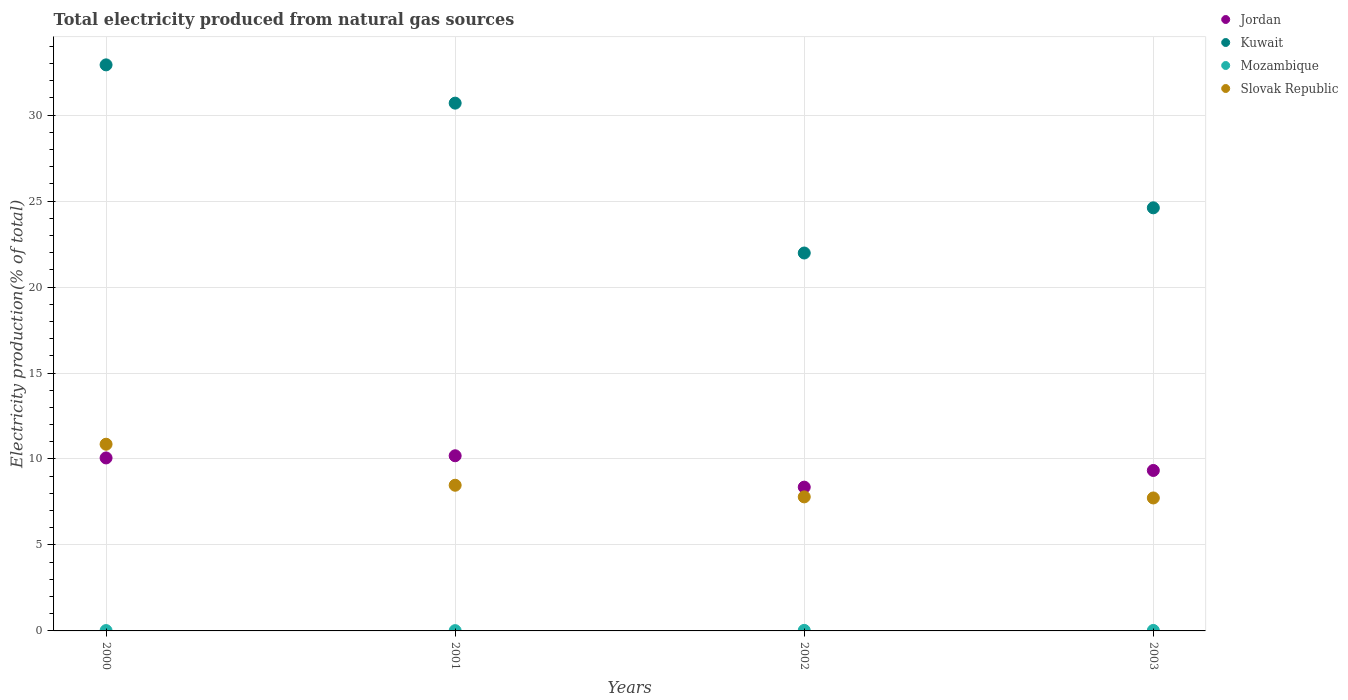Is the number of dotlines equal to the number of legend labels?
Provide a short and direct response. Yes. What is the total electricity produced in Slovak Republic in 2000?
Provide a short and direct response. 10.86. Across all years, what is the maximum total electricity produced in Kuwait?
Give a very brief answer. 32.92. Across all years, what is the minimum total electricity produced in Kuwait?
Your response must be concise. 21.98. What is the total total electricity produced in Slovak Republic in the graph?
Your response must be concise. 34.86. What is the difference between the total electricity produced in Mozambique in 2000 and that in 2002?
Ensure brevity in your answer.  -0.01. What is the difference between the total electricity produced in Mozambique in 2003 and the total electricity produced in Slovak Republic in 2000?
Your response must be concise. -10.83. What is the average total electricity produced in Jordan per year?
Make the answer very short. 9.49. In the year 2003, what is the difference between the total electricity produced in Mozambique and total electricity produced in Jordan?
Offer a terse response. -9.3. In how many years, is the total electricity produced in Slovak Republic greater than 31 %?
Your response must be concise. 0. What is the ratio of the total electricity produced in Jordan in 2001 to that in 2003?
Provide a short and direct response. 1.09. Is the difference between the total electricity produced in Mozambique in 2000 and 2002 greater than the difference between the total electricity produced in Jordan in 2000 and 2002?
Make the answer very short. No. What is the difference between the highest and the second highest total electricity produced in Kuwait?
Make the answer very short. 2.23. What is the difference between the highest and the lowest total electricity produced in Mozambique?
Your answer should be compact. 0.01. In how many years, is the total electricity produced in Mozambique greater than the average total electricity produced in Mozambique taken over all years?
Ensure brevity in your answer.  2. Is the sum of the total electricity produced in Mozambique in 2002 and 2003 greater than the maximum total electricity produced in Slovak Republic across all years?
Offer a very short reply. No. Is the total electricity produced in Kuwait strictly less than the total electricity produced in Mozambique over the years?
Your answer should be compact. No. How many years are there in the graph?
Offer a terse response. 4. What is the difference between two consecutive major ticks on the Y-axis?
Provide a short and direct response. 5. Are the values on the major ticks of Y-axis written in scientific E-notation?
Offer a very short reply. No. What is the title of the graph?
Your answer should be very brief. Total electricity produced from natural gas sources. What is the label or title of the X-axis?
Your answer should be compact. Years. What is the Electricity production(% of total) in Jordan in 2000?
Offer a very short reply. 10.06. What is the Electricity production(% of total) in Kuwait in 2000?
Provide a succinct answer. 32.92. What is the Electricity production(% of total) in Mozambique in 2000?
Provide a short and direct response. 0.02. What is the Electricity production(% of total) in Slovak Republic in 2000?
Offer a very short reply. 10.86. What is the Electricity production(% of total) of Jordan in 2001?
Ensure brevity in your answer.  10.19. What is the Electricity production(% of total) in Kuwait in 2001?
Provide a short and direct response. 30.69. What is the Electricity production(% of total) of Mozambique in 2001?
Give a very brief answer. 0.02. What is the Electricity production(% of total) of Slovak Republic in 2001?
Keep it short and to the point. 8.47. What is the Electricity production(% of total) of Jordan in 2002?
Provide a succinct answer. 8.36. What is the Electricity production(% of total) of Kuwait in 2002?
Give a very brief answer. 21.98. What is the Electricity production(% of total) in Mozambique in 2002?
Provide a succinct answer. 0.03. What is the Electricity production(% of total) of Slovak Republic in 2002?
Your response must be concise. 7.8. What is the Electricity production(% of total) of Jordan in 2003?
Your answer should be very brief. 9.33. What is the Electricity production(% of total) of Kuwait in 2003?
Keep it short and to the point. 24.61. What is the Electricity production(% of total) in Mozambique in 2003?
Offer a terse response. 0.03. What is the Electricity production(% of total) in Slovak Republic in 2003?
Your response must be concise. 7.73. Across all years, what is the maximum Electricity production(% of total) of Jordan?
Offer a terse response. 10.19. Across all years, what is the maximum Electricity production(% of total) of Kuwait?
Offer a very short reply. 32.92. Across all years, what is the maximum Electricity production(% of total) of Mozambique?
Provide a succinct answer. 0.03. Across all years, what is the maximum Electricity production(% of total) in Slovak Republic?
Provide a short and direct response. 10.86. Across all years, what is the minimum Electricity production(% of total) of Jordan?
Offer a very short reply. 8.36. Across all years, what is the minimum Electricity production(% of total) of Kuwait?
Give a very brief answer. 21.98. Across all years, what is the minimum Electricity production(% of total) in Mozambique?
Your response must be concise. 0.02. Across all years, what is the minimum Electricity production(% of total) in Slovak Republic?
Ensure brevity in your answer.  7.73. What is the total Electricity production(% of total) of Jordan in the graph?
Offer a terse response. 37.94. What is the total Electricity production(% of total) of Kuwait in the graph?
Your answer should be compact. 110.2. What is the total Electricity production(% of total) in Mozambique in the graph?
Keep it short and to the point. 0.1. What is the total Electricity production(% of total) in Slovak Republic in the graph?
Your response must be concise. 34.86. What is the difference between the Electricity production(% of total) in Jordan in 2000 and that in 2001?
Provide a short and direct response. -0.13. What is the difference between the Electricity production(% of total) in Kuwait in 2000 and that in 2001?
Your answer should be compact. 2.23. What is the difference between the Electricity production(% of total) in Mozambique in 2000 and that in 2001?
Your answer should be compact. 0. What is the difference between the Electricity production(% of total) in Slovak Republic in 2000 and that in 2001?
Give a very brief answer. 2.39. What is the difference between the Electricity production(% of total) of Jordan in 2000 and that in 2002?
Provide a short and direct response. 1.7. What is the difference between the Electricity production(% of total) of Kuwait in 2000 and that in 2002?
Your answer should be compact. 10.94. What is the difference between the Electricity production(% of total) of Mozambique in 2000 and that in 2002?
Your response must be concise. -0.01. What is the difference between the Electricity production(% of total) in Slovak Republic in 2000 and that in 2002?
Give a very brief answer. 3.06. What is the difference between the Electricity production(% of total) of Jordan in 2000 and that in 2003?
Your answer should be very brief. 0.73. What is the difference between the Electricity production(% of total) of Kuwait in 2000 and that in 2003?
Your answer should be compact. 8.31. What is the difference between the Electricity production(% of total) of Mozambique in 2000 and that in 2003?
Your answer should be compact. -0.01. What is the difference between the Electricity production(% of total) of Slovak Republic in 2000 and that in 2003?
Your answer should be very brief. 3.13. What is the difference between the Electricity production(% of total) in Jordan in 2001 and that in 2002?
Offer a terse response. 1.82. What is the difference between the Electricity production(% of total) of Kuwait in 2001 and that in 2002?
Offer a very short reply. 8.72. What is the difference between the Electricity production(% of total) of Mozambique in 2001 and that in 2002?
Ensure brevity in your answer.  -0.01. What is the difference between the Electricity production(% of total) of Slovak Republic in 2001 and that in 2002?
Make the answer very short. 0.68. What is the difference between the Electricity production(% of total) in Jordan in 2001 and that in 2003?
Provide a short and direct response. 0.85. What is the difference between the Electricity production(% of total) in Kuwait in 2001 and that in 2003?
Your answer should be compact. 6.09. What is the difference between the Electricity production(% of total) of Mozambique in 2001 and that in 2003?
Provide a short and direct response. -0.01. What is the difference between the Electricity production(% of total) in Slovak Republic in 2001 and that in 2003?
Give a very brief answer. 0.74. What is the difference between the Electricity production(% of total) of Jordan in 2002 and that in 2003?
Give a very brief answer. -0.97. What is the difference between the Electricity production(% of total) of Kuwait in 2002 and that in 2003?
Your response must be concise. -2.63. What is the difference between the Electricity production(% of total) in Mozambique in 2002 and that in 2003?
Provide a short and direct response. 0. What is the difference between the Electricity production(% of total) in Slovak Republic in 2002 and that in 2003?
Your answer should be very brief. 0.06. What is the difference between the Electricity production(% of total) of Jordan in 2000 and the Electricity production(% of total) of Kuwait in 2001?
Offer a terse response. -20.63. What is the difference between the Electricity production(% of total) of Jordan in 2000 and the Electricity production(% of total) of Mozambique in 2001?
Your response must be concise. 10.04. What is the difference between the Electricity production(% of total) in Jordan in 2000 and the Electricity production(% of total) in Slovak Republic in 2001?
Your response must be concise. 1.59. What is the difference between the Electricity production(% of total) of Kuwait in 2000 and the Electricity production(% of total) of Mozambique in 2001?
Provide a short and direct response. 32.9. What is the difference between the Electricity production(% of total) in Kuwait in 2000 and the Electricity production(% of total) in Slovak Republic in 2001?
Your answer should be very brief. 24.45. What is the difference between the Electricity production(% of total) in Mozambique in 2000 and the Electricity production(% of total) in Slovak Republic in 2001?
Your answer should be compact. -8.45. What is the difference between the Electricity production(% of total) of Jordan in 2000 and the Electricity production(% of total) of Kuwait in 2002?
Provide a succinct answer. -11.92. What is the difference between the Electricity production(% of total) of Jordan in 2000 and the Electricity production(% of total) of Mozambique in 2002?
Provide a short and direct response. 10.03. What is the difference between the Electricity production(% of total) in Jordan in 2000 and the Electricity production(% of total) in Slovak Republic in 2002?
Ensure brevity in your answer.  2.27. What is the difference between the Electricity production(% of total) of Kuwait in 2000 and the Electricity production(% of total) of Mozambique in 2002?
Keep it short and to the point. 32.89. What is the difference between the Electricity production(% of total) in Kuwait in 2000 and the Electricity production(% of total) in Slovak Republic in 2002?
Keep it short and to the point. 25.13. What is the difference between the Electricity production(% of total) of Mozambique in 2000 and the Electricity production(% of total) of Slovak Republic in 2002?
Provide a short and direct response. -7.77. What is the difference between the Electricity production(% of total) in Jordan in 2000 and the Electricity production(% of total) in Kuwait in 2003?
Make the answer very short. -14.55. What is the difference between the Electricity production(% of total) in Jordan in 2000 and the Electricity production(% of total) in Mozambique in 2003?
Provide a short and direct response. 10.03. What is the difference between the Electricity production(% of total) in Jordan in 2000 and the Electricity production(% of total) in Slovak Republic in 2003?
Make the answer very short. 2.33. What is the difference between the Electricity production(% of total) in Kuwait in 2000 and the Electricity production(% of total) in Mozambique in 2003?
Make the answer very short. 32.89. What is the difference between the Electricity production(% of total) of Kuwait in 2000 and the Electricity production(% of total) of Slovak Republic in 2003?
Your answer should be compact. 25.19. What is the difference between the Electricity production(% of total) of Mozambique in 2000 and the Electricity production(% of total) of Slovak Republic in 2003?
Your answer should be compact. -7.71. What is the difference between the Electricity production(% of total) of Jordan in 2001 and the Electricity production(% of total) of Kuwait in 2002?
Provide a short and direct response. -11.79. What is the difference between the Electricity production(% of total) in Jordan in 2001 and the Electricity production(% of total) in Mozambique in 2002?
Offer a terse response. 10.16. What is the difference between the Electricity production(% of total) of Jordan in 2001 and the Electricity production(% of total) of Slovak Republic in 2002?
Offer a terse response. 2.39. What is the difference between the Electricity production(% of total) of Kuwait in 2001 and the Electricity production(% of total) of Mozambique in 2002?
Your answer should be very brief. 30.66. What is the difference between the Electricity production(% of total) in Kuwait in 2001 and the Electricity production(% of total) in Slovak Republic in 2002?
Make the answer very short. 22.9. What is the difference between the Electricity production(% of total) in Mozambique in 2001 and the Electricity production(% of total) in Slovak Republic in 2002?
Provide a succinct answer. -7.78. What is the difference between the Electricity production(% of total) of Jordan in 2001 and the Electricity production(% of total) of Kuwait in 2003?
Your answer should be very brief. -14.42. What is the difference between the Electricity production(% of total) in Jordan in 2001 and the Electricity production(% of total) in Mozambique in 2003?
Your answer should be very brief. 10.16. What is the difference between the Electricity production(% of total) of Jordan in 2001 and the Electricity production(% of total) of Slovak Republic in 2003?
Keep it short and to the point. 2.45. What is the difference between the Electricity production(% of total) in Kuwait in 2001 and the Electricity production(% of total) in Mozambique in 2003?
Offer a very short reply. 30.67. What is the difference between the Electricity production(% of total) of Kuwait in 2001 and the Electricity production(% of total) of Slovak Republic in 2003?
Give a very brief answer. 22.96. What is the difference between the Electricity production(% of total) in Mozambique in 2001 and the Electricity production(% of total) in Slovak Republic in 2003?
Provide a short and direct response. -7.72. What is the difference between the Electricity production(% of total) in Jordan in 2002 and the Electricity production(% of total) in Kuwait in 2003?
Make the answer very short. -16.24. What is the difference between the Electricity production(% of total) of Jordan in 2002 and the Electricity production(% of total) of Mozambique in 2003?
Provide a succinct answer. 8.33. What is the difference between the Electricity production(% of total) of Jordan in 2002 and the Electricity production(% of total) of Slovak Republic in 2003?
Provide a short and direct response. 0.63. What is the difference between the Electricity production(% of total) in Kuwait in 2002 and the Electricity production(% of total) in Mozambique in 2003?
Give a very brief answer. 21.95. What is the difference between the Electricity production(% of total) in Kuwait in 2002 and the Electricity production(% of total) in Slovak Republic in 2003?
Give a very brief answer. 14.25. What is the difference between the Electricity production(% of total) in Mozambique in 2002 and the Electricity production(% of total) in Slovak Republic in 2003?
Ensure brevity in your answer.  -7.7. What is the average Electricity production(% of total) of Jordan per year?
Offer a terse response. 9.49. What is the average Electricity production(% of total) in Kuwait per year?
Give a very brief answer. 27.55. What is the average Electricity production(% of total) of Mozambique per year?
Offer a terse response. 0.02. What is the average Electricity production(% of total) of Slovak Republic per year?
Offer a very short reply. 8.71. In the year 2000, what is the difference between the Electricity production(% of total) of Jordan and Electricity production(% of total) of Kuwait?
Provide a succinct answer. -22.86. In the year 2000, what is the difference between the Electricity production(% of total) of Jordan and Electricity production(% of total) of Mozambique?
Offer a very short reply. 10.04. In the year 2000, what is the difference between the Electricity production(% of total) of Jordan and Electricity production(% of total) of Slovak Republic?
Your answer should be very brief. -0.8. In the year 2000, what is the difference between the Electricity production(% of total) of Kuwait and Electricity production(% of total) of Mozambique?
Give a very brief answer. 32.9. In the year 2000, what is the difference between the Electricity production(% of total) in Kuwait and Electricity production(% of total) in Slovak Republic?
Keep it short and to the point. 22.06. In the year 2000, what is the difference between the Electricity production(% of total) of Mozambique and Electricity production(% of total) of Slovak Republic?
Give a very brief answer. -10.84. In the year 2001, what is the difference between the Electricity production(% of total) of Jordan and Electricity production(% of total) of Kuwait?
Provide a succinct answer. -20.51. In the year 2001, what is the difference between the Electricity production(% of total) in Jordan and Electricity production(% of total) in Mozambique?
Ensure brevity in your answer.  10.17. In the year 2001, what is the difference between the Electricity production(% of total) of Jordan and Electricity production(% of total) of Slovak Republic?
Your answer should be compact. 1.71. In the year 2001, what is the difference between the Electricity production(% of total) in Kuwait and Electricity production(% of total) in Mozambique?
Your answer should be compact. 30.68. In the year 2001, what is the difference between the Electricity production(% of total) in Kuwait and Electricity production(% of total) in Slovak Republic?
Offer a terse response. 22.22. In the year 2001, what is the difference between the Electricity production(% of total) of Mozambique and Electricity production(% of total) of Slovak Republic?
Your answer should be very brief. -8.46. In the year 2002, what is the difference between the Electricity production(% of total) in Jordan and Electricity production(% of total) in Kuwait?
Keep it short and to the point. -13.62. In the year 2002, what is the difference between the Electricity production(% of total) in Jordan and Electricity production(% of total) in Mozambique?
Keep it short and to the point. 8.33. In the year 2002, what is the difference between the Electricity production(% of total) in Jordan and Electricity production(% of total) in Slovak Republic?
Your response must be concise. 0.57. In the year 2002, what is the difference between the Electricity production(% of total) in Kuwait and Electricity production(% of total) in Mozambique?
Provide a short and direct response. 21.95. In the year 2002, what is the difference between the Electricity production(% of total) of Kuwait and Electricity production(% of total) of Slovak Republic?
Your answer should be very brief. 14.18. In the year 2002, what is the difference between the Electricity production(% of total) in Mozambique and Electricity production(% of total) in Slovak Republic?
Your answer should be very brief. -7.76. In the year 2003, what is the difference between the Electricity production(% of total) in Jordan and Electricity production(% of total) in Kuwait?
Make the answer very short. -15.27. In the year 2003, what is the difference between the Electricity production(% of total) of Jordan and Electricity production(% of total) of Mozambique?
Provide a succinct answer. 9.3. In the year 2003, what is the difference between the Electricity production(% of total) in Jordan and Electricity production(% of total) in Slovak Republic?
Offer a very short reply. 1.6. In the year 2003, what is the difference between the Electricity production(% of total) of Kuwait and Electricity production(% of total) of Mozambique?
Your answer should be compact. 24.58. In the year 2003, what is the difference between the Electricity production(% of total) of Kuwait and Electricity production(% of total) of Slovak Republic?
Offer a very short reply. 16.87. In the year 2003, what is the difference between the Electricity production(% of total) of Mozambique and Electricity production(% of total) of Slovak Republic?
Give a very brief answer. -7.71. What is the ratio of the Electricity production(% of total) in Jordan in 2000 to that in 2001?
Keep it short and to the point. 0.99. What is the ratio of the Electricity production(% of total) in Kuwait in 2000 to that in 2001?
Offer a terse response. 1.07. What is the ratio of the Electricity production(% of total) of Mozambique in 2000 to that in 2001?
Make the answer very short. 1.23. What is the ratio of the Electricity production(% of total) of Slovak Republic in 2000 to that in 2001?
Give a very brief answer. 1.28. What is the ratio of the Electricity production(% of total) of Jordan in 2000 to that in 2002?
Your answer should be very brief. 1.2. What is the ratio of the Electricity production(% of total) in Kuwait in 2000 to that in 2002?
Keep it short and to the point. 1.5. What is the ratio of the Electricity production(% of total) of Mozambique in 2000 to that in 2002?
Give a very brief answer. 0.66. What is the ratio of the Electricity production(% of total) in Slovak Republic in 2000 to that in 2002?
Keep it short and to the point. 1.39. What is the ratio of the Electricity production(% of total) in Jordan in 2000 to that in 2003?
Provide a short and direct response. 1.08. What is the ratio of the Electricity production(% of total) of Kuwait in 2000 to that in 2003?
Give a very brief answer. 1.34. What is the ratio of the Electricity production(% of total) of Mozambique in 2000 to that in 2003?
Give a very brief answer. 0.75. What is the ratio of the Electricity production(% of total) in Slovak Republic in 2000 to that in 2003?
Your response must be concise. 1.4. What is the ratio of the Electricity production(% of total) in Jordan in 2001 to that in 2002?
Your answer should be very brief. 1.22. What is the ratio of the Electricity production(% of total) of Kuwait in 2001 to that in 2002?
Give a very brief answer. 1.4. What is the ratio of the Electricity production(% of total) in Mozambique in 2001 to that in 2002?
Give a very brief answer. 0.53. What is the ratio of the Electricity production(% of total) in Slovak Republic in 2001 to that in 2002?
Provide a succinct answer. 1.09. What is the ratio of the Electricity production(% of total) of Jordan in 2001 to that in 2003?
Offer a terse response. 1.09. What is the ratio of the Electricity production(% of total) in Kuwait in 2001 to that in 2003?
Keep it short and to the point. 1.25. What is the ratio of the Electricity production(% of total) in Mozambique in 2001 to that in 2003?
Provide a succinct answer. 0.61. What is the ratio of the Electricity production(% of total) of Slovak Republic in 2001 to that in 2003?
Offer a very short reply. 1.1. What is the ratio of the Electricity production(% of total) of Jordan in 2002 to that in 2003?
Offer a very short reply. 0.9. What is the ratio of the Electricity production(% of total) in Kuwait in 2002 to that in 2003?
Your answer should be compact. 0.89. What is the ratio of the Electricity production(% of total) of Mozambique in 2002 to that in 2003?
Your answer should be compact. 1.14. What is the ratio of the Electricity production(% of total) of Slovak Republic in 2002 to that in 2003?
Give a very brief answer. 1.01. What is the difference between the highest and the second highest Electricity production(% of total) in Jordan?
Your answer should be very brief. 0.13. What is the difference between the highest and the second highest Electricity production(% of total) of Kuwait?
Keep it short and to the point. 2.23. What is the difference between the highest and the second highest Electricity production(% of total) in Mozambique?
Your answer should be compact. 0. What is the difference between the highest and the second highest Electricity production(% of total) in Slovak Republic?
Give a very brief answer. 2.39. What is the difference between the highest and the lowest Electricity production(% of total) in Jordan?
Keep it short and to the point. 1.82. What is the difference between the highest and the lowest Electricity production(% of total) in Kuwait?
Provide a short and direct response. 10.94. What is the difference between the highest and the lowest Electricity production(% of total) of Mozambique?
Give a very brief answer. 0.01. What is the difference between the highest and the lowest Electricity production(% of total) in Slovak Republic?
Offer a terse response. 3.13. 